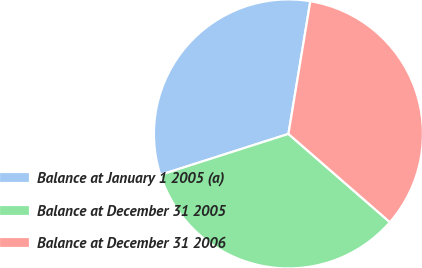Convert chart. <chart><loc_0><loc_0><loc_500><loc_500><pie_chart><fcel>Balance at January 1 2005 (a)<fcel>Balance at December 31 2005<fcel>Balance at December 31 2006<nl><fcel>32.53%<fcel>33.68%<fcel>33.79%<nl></chart> 